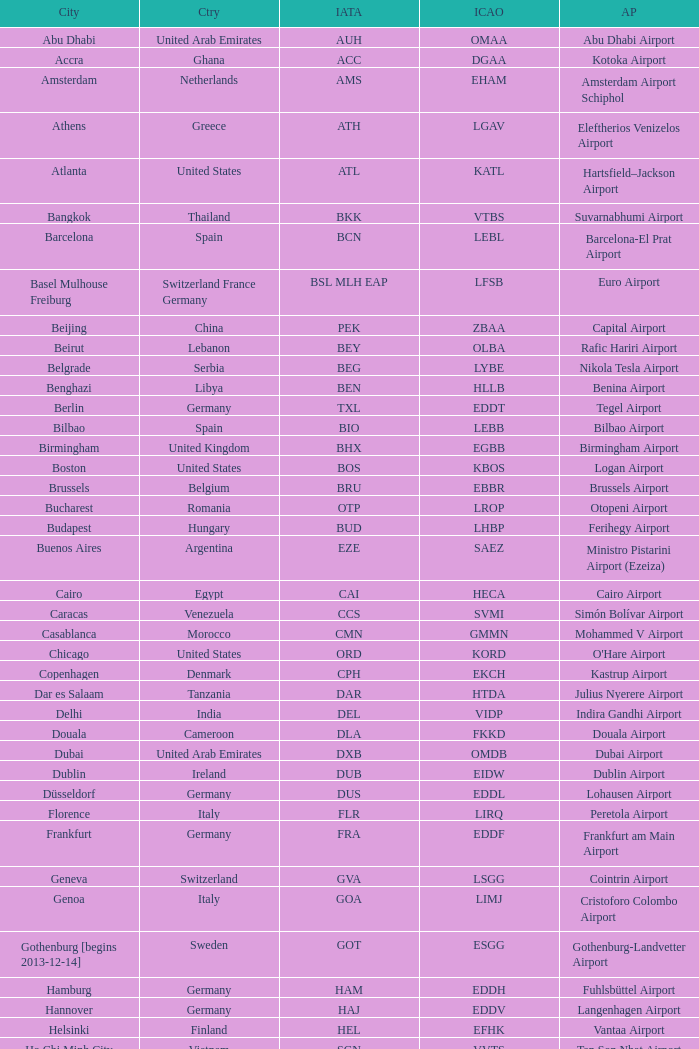What is the IATA of galeão airport? GIG. 